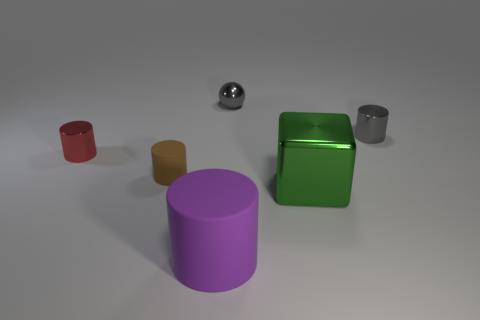Subtract 1 cylinders. How many cylinders are left? 3 Add 2 big metallic objects. How many objects exist? 8 Subtract all cubes. How many objects are left? 5 Add 4 big green blocks. How many big green blocks are left? 5 Add 6 brown metal cubes. How many brown metal cubes exist? 6 Subtract 0 blue balls. How many objects are left? 6 Subtract all big yellow rubber cylinders. Subtract all tiny brown rubber cylinders. How many objects are left? 5 